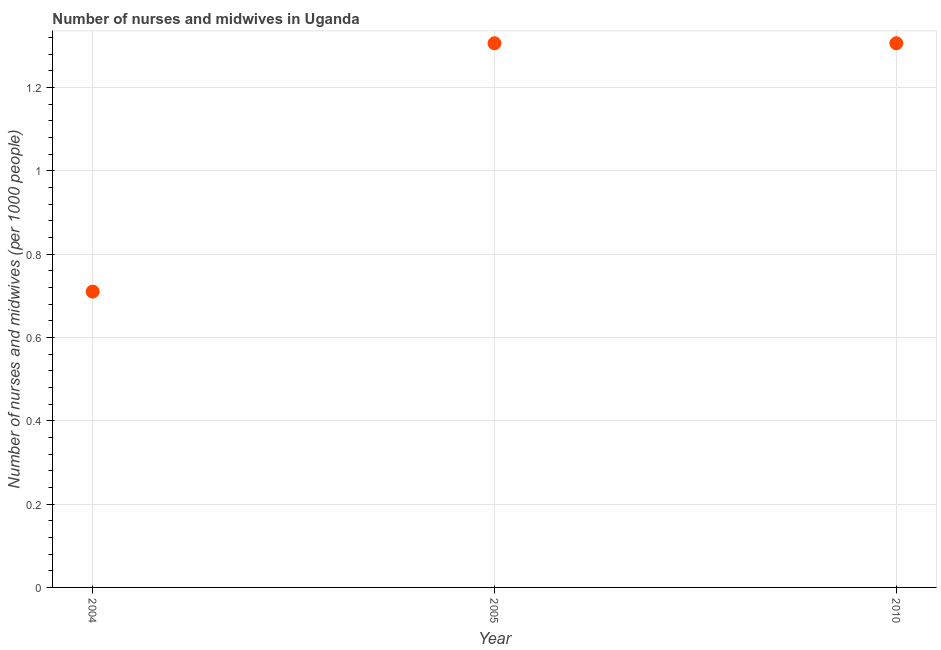What is the number of nurses and midwives in 2010?
Ensure brevity in your answer.  1.31. Across all years, what is the maximum number of nurses and midwives?
Your answer should be very brief. 1.31. Across all years, what is the minimum number of nurses and midwives?
Ensure brevity in your answer.  0.71. What is the sum of the number of nurses and midwives?
Make the answer very short. 3.32. What is the difference between the number of nurses and midwives in 2004 and 2010?
Your answer should be compact. -0.6. What is the average number of nurses and midwives per year?
Offer a terse response. 1.11. What is the median number of nurses and midwives?
Provide a short and direct response. 1.31. What is the ratio of the number of nurses and midwives in 2004 to that in 2005?
Provide a short and direct response. 0.54. Is the sum of the number of nurses and midwives in 2004 and 2010 greater than the maximum number of nurses and midwives across all years?
Provide a short and direct response. Yes. What is the difference between the highest and the lowest number of nurses and midwives?
Ensure brevity in your answer.  0.6. In how many years, is the number of nurses and midwives greater than the average number of nurses and midwives taken over all years?
Offer a very short reply. 2. Does the number of nurses and midwives monotonically increase over the years?
Offer a terse response. No. How many dotlines are there?
Your response must be concise. 1. What is the difference between two consecutive major ticks on the Y-axis?
Offer a terse response. 0.2. Are the values on the major ticks of Y-axis written in scientific E-notation?
Your answer should be very brief. No. Does the graph contain any zero values?
Ensure brevity in your answer.  No. What is the title of the graph?
Your answer should be very brief. Number of nurses and midwives in Uganda. What is the label or title of the Y-axis?
Keep it short and to the point. Number of nurses and midwives (per 1000 people). What is the Number of nurses and midwives (per 1000 people) in 2004?
Your response must be concise. 0.71. What is the Number of nurses and midwives (per 1000 people) in 2005?
Provide a succinct answer. 1.31. What is the Number of nurses and midwives (per 1000 people) in 2010?
Provide a short and direct response. 1.31. What is the difference between the Number of nurses and midwives (per 1000 people) in 2004 and 2005?
Provide a succinct answer. -0.6. What is the difference between the Number of nurses and midwives (per 1000 people) in 2004 and 2010?
Provide a short and direct response. -0.6. What is the ratio of the Number of nurses and midwives (per 1000 people) in 2004 to that in 2005?
Give a very brief answer. 0.54. What is the ratio of the Number of nurses and midwives (per 1000 people) in 2004 to that in 2010?
Ensure brevity in your answer.  0.54. What is the ratio of the Number of nurses and midwives (per 1000 people) in 2005 to that in 2010?
Provide a succinct answer. 1. 